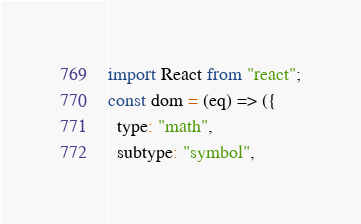<code> <loc_0><loc_0><loc_500><loc_500><_JavaScript_>import React from "react";
const dom = (eq) => ({
  type: "math",
  subtype: "symbol",</code> 